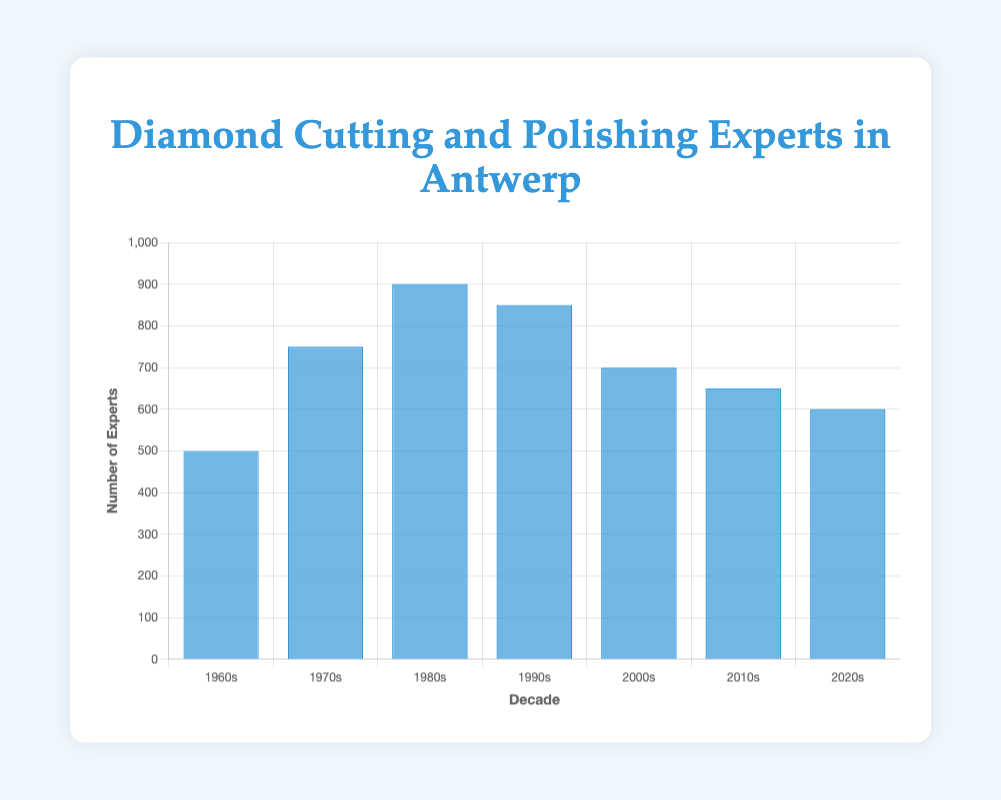Which decade had the highest number of cutting and polishing experts? The bar representing the 1980s is the highest among all the decades, indicating that it had the most experts.
Answer: 1980s Which decade had the lowest number of cutting and polishing experts? The bar representing the 1960s is the shortest among all the decades, indicating that it had the least number of experts.
Answer: 1960s What's the difference in the number of experts between the 1980s and 2020s? The number of experts in the 1980s is 900, and in the 2020s is 600. Subtracting these gives 900 - 600 = 300.
Answer: 300 What's the total number of experts in the 1970s and 2000s combined? The number of experts in the 1970s is 750, and in the 2000s is 700. Adding these gives 750 + 700 = 1450.
Answer: 1450 How has the number of experts changed from the 1960s to the 1970s? The number of experts increased from 500 in the 1960s to 750 in the 1970s. The difference is 750 - 500 = 250, indicating an increase.
Answer: Increased by 250 How does the number of experts in the 2010s compare to the 2000s? The bar for the 2010s is shorter than the one for the 2000s. The number of experts in the 2010s is 650, which is 50 less than the 700 in the 2000s.
Answer: 50 less What was the trend in the number of experts from the 1980s to the 2020s? The number of experts peaked in the 1980s at 900 and showed a decreasing trend in subsequent decades, with numbers going down to 850 in the 1990s, 700 in the 2000s, 650 in the 2010s, and 600 in the 2020s.
Answer: Decreasing Identify the decade with a notable entity called "Rosy Blue" and its number of experts. The notable entity "Rosy Blue" corresponds to the 1980s. The bar for the 1980s indicates 900 experts.
Answer: 1980s, 900 experts Which two decades have the closest number of experts, and what is the difference? The number of experts in the 2010s is 650, and in the 2020s is 600. The difference is 650 - 600 = 50, which is the smallest difference compared to other decades.
Answer: 2010s and 2020s, 50 